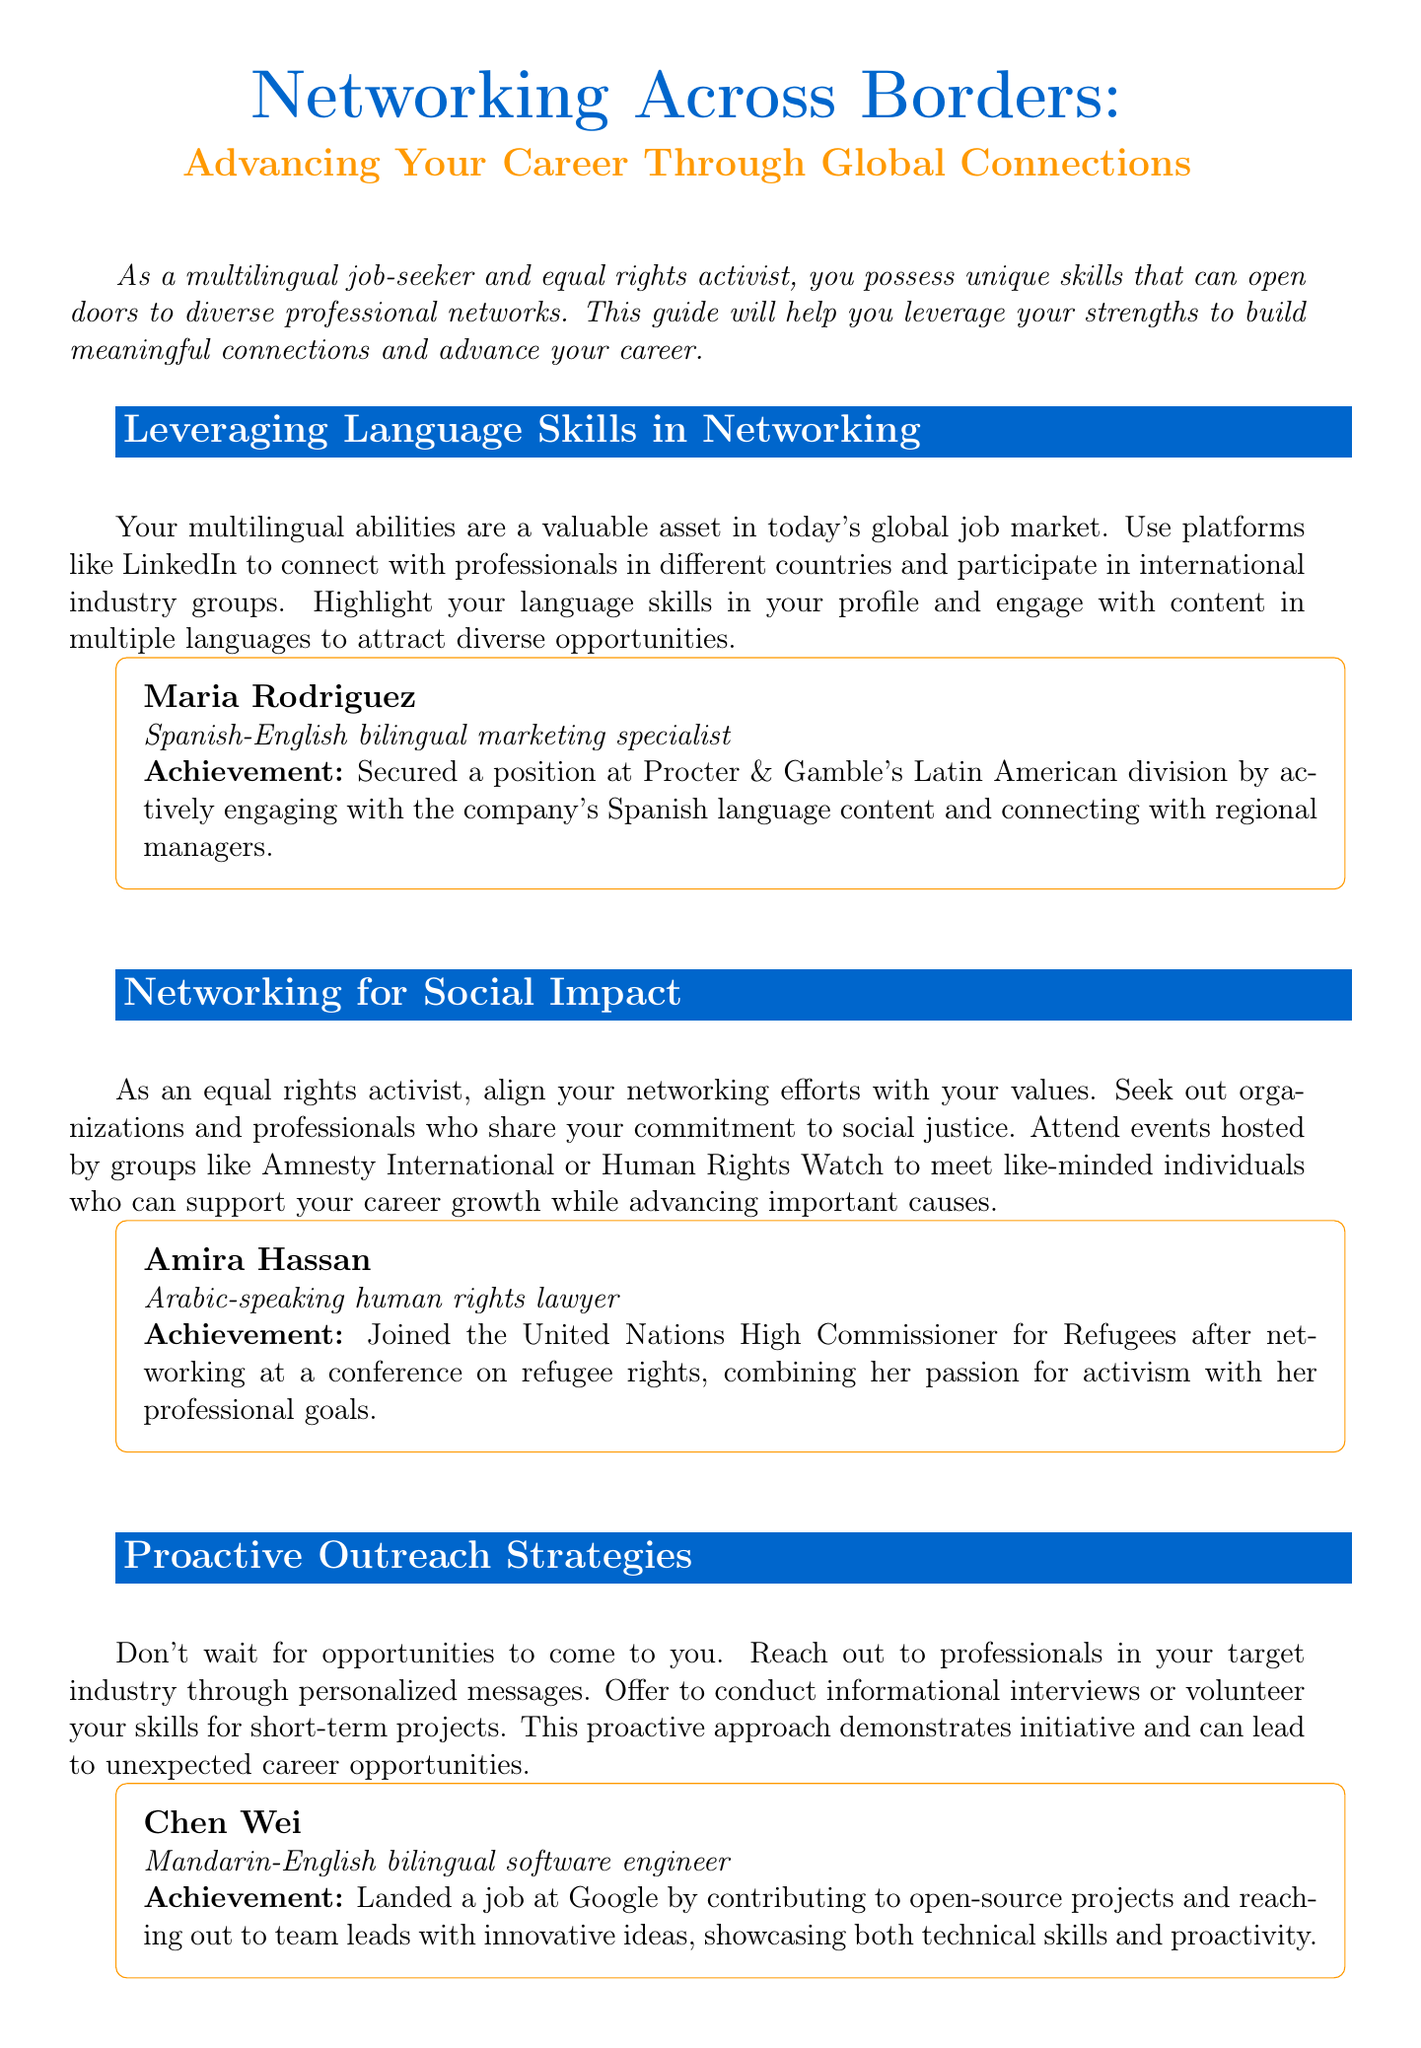What is the title of the newsletter? The title of the newsletter is presented at the top as "Networking Across Borders: Advancing Your Career Through Global Connections."
Answer: Networking Across Borders: Advancing Your Career Through Global Connections Who is featured in the success story related to language skills? The success story under "Leveraging Language Skills in Networking" features Maria Rodriguez, who is a bilingual marketing specialist.
Answer: Maria Rodriguez What organization did Amira Hassan join? Amira Hassan's achievement is noted as joining the United Nations High Commissioner for Refugees.
Answer: United Nations High Commissioner for Refugees What proactive strategy involves reaching out to professionals? The document discusses the importance of conducting informational interviews to demonstrate initiative.
Answer: Informational interviews Which event does Jamal Thompson credit for securing seed funding? Jamal Thompson secured funding by networking at a specific conference mentioned in the document.
Answer: National Minority Supplier Development Council's annual conference What is one app recommended for enhancing language skills? The document lists Duolingo as a useful app for language improvement.
Answer: Duolingo How many sections does the newsletter have? The main sections of the newsletter, including various topics, are counted in the document, which provides a total of four main sections.
Answer: Four What type of interactive element tests networking IQ? The document describes a quiz as an interactive element assessing current networking strategies.
Answer: Quiz What is the call to action in the newsletter? The call to action encourages readers to update their LinkedIn profiles and choose a networking event to attend.
Answer: Update LinkedIn profile and attend a networking event 